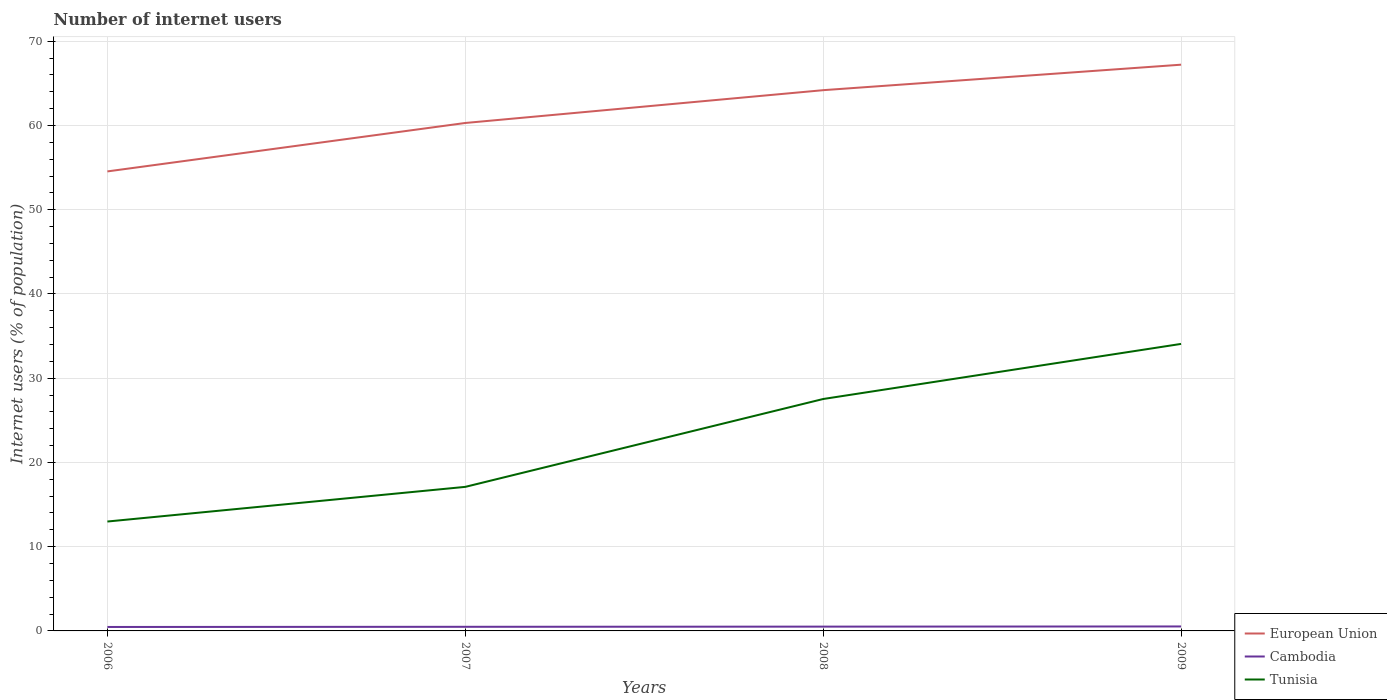How many different coloured lines are there?
Offer a very short reply. 3. Across all years, what is the maximum number of internet users in Cambodia?
Ensure brevity in your answer.  0.47. In which year was the number of internet users in Tunisia maximum?
Offer a terse response. 2006. What is the total number of internet users in Cambodia in the graph?
Provide a short and direct response. -0.02. What is the difference between the highest and the second highest number of internet users in Cambodia?
Provide a short and direct response. 0.06. What is the difference between the highest and the lowest number of internet users in Cambodia?
Offer a very short reply. 2. Is the number of internet users in Cambodia strictly greater than the number of internet users in European Union over the years?
Keep it short and to the point. Yes. How many lines are there?
Keep it short and to the point. 3. Are the values on the major ticks of Y-axis written in scientific E-notation?
Give a very brief answer. No. Does the graph contain grids?
Give a very brief answer. Yes. How are the legend labels stacked?
Your response must be concise. Vertical. What is the title of the graph?
Make the answer very short. Number of internet users. Does "Slovak Republic" appear as one of the legend labels in the graph?
Your response must be concise. No. What is the label or title of the X-axis?
Offer a terse response. Years. What is the label or title of the Y-axis?
Your answer should be very brief. Internet users (% of population). What is the Internet users (% of population) of European Union in 2006?
Keep it short and to the point. 54.55. What is the Internet users (% of population) of Cambodia in 2006?
Provide a succinct answer. 0.47. What is the Internet users (% of population) of Tunisia in 2006?
Your answer should be compact. 12.99. What is the Internet users (% of population) of European Union in 2007?
Offer a very short reply. 60.3. What is the Internet users (% of population) in Cambodia in 2007?
Make the answer very short. 0.49. What is the Internet users (% of population) of European Union in 2008?
Your answer should be very brief. 64.19. What is the Internet users (% of population) in Cambodia in 2008?
Offer a terse response. 0.51. What is the Internet users (% of population) in Tunisia in 2008?
Your response must be concise. 27.53. What is the Internet users (% of population) in European Union in 2009?
Your answer should be compact. 67.21. What is the Internet users (% of population) of Cambodia in 2009?
Provide a succinct answer. 0.53. What is the Internet users (% of population) of Tunisia in 2009?
Your answer should be very brief. 34.07. Across all years, what is the maximum Internet users (% of population) in European Union?
Your response must be concise. 67.21. Across all years, what is the maximum Internet users (% of population) in Cambodia?
Your response must be concise. 0.53. Across all years, what is the maximum Internet users (% of population) of Tunisia?
Provide a short and direct response. 34.07. Across all years, what is the minimum Internet users (% of population) in European Union?
Your response must be concise. 54.55. Across all years, what is the minimum Internet users (% of population) in Cambodia?
Your answer should be very brief. 0.47. Across all years, what is the minimum Internet users (% of population) in Tunisia?
Keep it short and to the point. 12.99. What is the total Internet users (% of population) of European Union in the graph?
Offer a terse response. 246.25. What is the total Internet users (% of population) in Cambodia in the graph?
Provide a short and direct response. 2. What is the total Internet users (% of population) in Tunisia in the graph?
Keep it short and to the point. 91.69. What is the difference between the Internet users (% of population) in European Union in 2006 and that in 2007?
Make the answer very short. -5.75. What is the difference between the Internet users (% of population) of Cambodia in 2006 and that in 2007?
Make the answer very short. -0.02. What is the difference between the Internet users (% of population) of Tunisia in 2006 and that in 2007?
Your answer should be very brief. -4.11. What is the difference between the Internet users (% of population) of European Union in 2006 and that in 2008?
Make the answer very short. -9.64. What is the difference between the Internet users (% of population) of Cambodia in 2006 and that in 2008?
Your answer should be very brief. -0.04. What is the difference between the Internet users (% of population) of Tunisia in 2006 and that in 2008?
Provide a succinct answer. -14.54. What is the difference between the Internet users (% of population) of European Union in 2006 and that in 2009?
Your answer should be very brief. -12.67. What is the difference between the Internet users (% of population) in Cambodia in 2006 and that in 2009?
Your answer should be very brief. -0.06. What is the difference between the Internet users (% of population) of Tunisia in 2006 and that in 2009?
Provide a succinct answer. -21.08. What is the difference between the Internet users (% of population) in European Union in 2007 and that in 2008?
Provide a succinct answer. -3.89. What is the difference between the Internet users (% of population) in Cambodia in 2007 and that in 2008?
Keep it short and to the point. -0.02. What is the difference between the Internet users (% of population) of Tunisia in 2007 and that in 2008?
Offer a very short reply. -10.43. What is the difference between the Internet users (% of population) in European Union in 2007 and that in 2009?
Provide a succinct answer. -6.92. What is the difference between the Internet users (% of population) in Cambodia in 2007 and that in 2009?
Offer a very short reply. -0.04. What is the difference between the Internet users (% of population) in Tunisia in 2007 and that in 2009?
Give a very brief answer. -16.97. What is the difference between the Internet users (% of population) in European Union in 2008 and that in 2009?
Ensure brevity in your answer.  -3.03. What is the difference between the Internet users (% of population) of Cambodia in 2008 and that in 2009?
Provide a succinct answer. -0.02. What is the difference between the Internet users (% of population) in Tunisia in 2008 and that in 2009?
Offer a terse response. -6.54. What is the difference between the Internet users (% of population) in European Union in 2006 and the Internet users (% of population) in Cambodia in 2007?
Give a very brief answer. 54.06. What is the difference between the Internet users (% of population) in European Union in 2006 and the Internet users (% of population) in Tunisia in 2007?
Your answer should be compact. 37.45. What is the difference between the Internet users (% of population) in Cambodia in 2006 and the Internet users (% of population) in Tunisia in 2007?
Your response must be concise. -16.63. What is the difference between the Internet users (% of population) in European Union in 2006 and the Internet users (% of population) in Cambodia in 2008?
Give a very brief answer. 54.04. What is the difference between the Internet users (% of population) in European Union in 2006 and the Internet users (% of population) in Tunisia in 2008?
Provide a short and direct response. 27.02. What is the difference between the Internet users (% of population) in Cambodia in 2006 and the Internet users (% of population) in Tunisia in 2008?
Give a very brief answer. -27.06. What is the difference between the Internet users (% of population) in European Union in 2006 and the Internet users (% of population) in Cambodia in 2009?
Give a very brief answer. 54.02. What is the difference between the Internet users (% of population) in European Union in 2006 and the Internet users (% of population) in Tunisia in 2009?
Give a very brief answer. 20.48. What is the difference between the Internet users (% of population) of Cambodia in 2006 and the Internet users (% of population) of Tunisia in 2009?
Your response must be concise. -33.6. What is the difference between the Internet users (% of population) of European Union in 2007 and the Internet users (% of population) of Cambodia in 2008?
Your response must be concise. 59.79. What is the difference between the Internet users (% of population) of European Union in 2007 and the Internet users (% of population) of Tunisia in 2008?
Ensure brevity in your answer.  32.77. What is the difference between the Internet users (% of population) of Cambodia in 2007 and the Internet users (% of population) of Tunisia in 2008?
Provide a succinct answer. -27.04. What is the difference between the Internet users (% of population) of European Union in 2007 and the Internet users (% of population) of Cambodia in 2009?
Provide a short and direct response. 59.77. What is the difference between the Internet users (% of population) of European Union in 2007 and the Internet users (% of population) of Tunisia in 2009?
Keep it short and to the point. 26.23. What is the difference between the Internet users (% of population) of Cambodia in 2007 and the Internet users (% of population) of Tunisia in 2009?
Your response must be concise. -33.58. What is the difference between the Internet users (% of population) of European Union in 2008 and the Internet users (% of population) of Cambodia in 2009?
Keep it short and to the point. 63.66. What is the difference between the Internet users (% of population) of European Union in 2008 and the Internet users (% of population) of Tunisia in 2009?
Give a very brief answer. 30.12. What is the difference between the Internet users (% of population) of Cambodia in 2008 and the Internet users (% of population) of Tunisia in 2009?
Your response must be concise. -33.56. What is the average Internet users (% of population) of European Union per year?
Provide a succinct answer. 61.56. What is the average Internet users (% of population) in Cambodia per year?
Make the answer very short. 0.5. What is the average Internet users (% of population) of Tunisia per year?
Your answer should be very brief. 22.92. In the year 2006, what is the difference between the Internet users (% of population) of European Union and Internet users (% of population) of Cambodia?
Provide a short and direct response. 54.08. In the year 2006, what is the difference between the Internet users (% of population) of European Union and Internet users (% of population) of Tunisia?
Provide a short and direct response. 41.56. In the year 2006, what is the difference between the Internet users (% of population) in Cambodia and Internet users (% of population) in Tunisia?
Provide a succinct answer. -12.52. In the year 2007, what is the difference between the Internet users (% of population) in European Union and Internet users (% of population) in Cambodia?
Your answer should be compact. 59.81. In the year 2007, what is the difference between the Internet users (% of population) of European Union and Internet users (% of population) of Tunisia?
Offer a very short reply. 43.2. In the year 2007, what is the difference between the Internet users (% of population) in Cambodia and Internet users (% of population) in Tunisia?
Make the answer very short. -16.61. In the year 2008, what is the difference between the Internet users (% of population) of European Union and Internet users (% of population) of Cambodia?
Give a very brief answer. 63.68. In the year 2008, what is the difference between the Internet users (% of population) in European Union and Internet users (% of population) in Tunisia?
Your answer should be very brief. 36.66. In the year 2008, what is the difference between the Internet users (% of population) of Cambodia and Internet users (% of population) of Tunisia?
Keep it short and to the point. -27.02. In the year 2009, what is the difference between the Internet users (% of population) of European Union and Internet users (% of population) of Cambodia?
Provide a short and direct response. 66.68. In the year 2009, what is the difference between the Internet users (% of population) of European Union and Internet users (% of population) of Tunisia?
Give a very brief answer. 33.14. In the year 2009, what is the difference between the Internet users (% of population) of Cambodia and Internet users (% of population) of Tunisia?
Offer a terse response. -33.54. What is the ratio of the Internet users (% of population) of European Union in 2006 to that in 2007?
Your response must be concise. 0.9. What is the ratio of the Internet users (% of population) in Cambodia in 2006 to that in 2007?
Offer a very short reply. 0.96. What is the ratio of the Internet users (% of population) of Tunisia in 2006 to that in 2007?
Keep it short and to the point. 0.76. What is the ratio of the Internet users (% of population) of European Union in 2006 to that in 2008?
Your response must be concise. 0.85. What is the ratio of the Internet users (% of population) of Cambodia in 2006 to that in 2008?
Provide a short and direct response. 0.92. What is the ratio of the Internet users (% of population) in Tunisia in 2006 to that in 2008?
Your answer should be very brief. 0.47. What is the ratio of the Internet users (% of population) in European Union in 2006 to that in 2009?
Offer a very short reply. 0.81. What is the ratio of the Internet users (% of population) in Cambodia in 2006 to that in 2009?
Provide a succinct answer. 0.88. What is the ratio of the Internet users (% of population) of Tunisia in 2006 to that in 2009?
Provide a succinct answer. 0.38. What is the ratio of the Internet users (% of population) of European Union in 2007 to that in 2008?
Your response must be concise. 0.94. What is the ratio of the Internet users (% of population) in Cambodia in 2007 to that in 2008?
Your response must be concise. 0.96. What is the ratio of the Internet users (% of population) of Tunisia in 2007 to that in 2008?
Keep it short and to the point. 0.62. What is the ratio of the Internet users (% of population) of European Union in 2007 to that in 2009?
Your answer should be compact. 0.9. What is the ratio of the Internet users (% of population) of Cambodia in 2007 to that in 2009?
Make the answer very short. 0.92. What is the ratio of the Internet users (% of population) in Tunisia in 2007 to that in 2009?
Provide a short and direct response. 0.5. What is the ratio of the Internet users (% of population) of European Union in 2008 to that in 2009?
Offer a very short reply. 0.95. What is the ratio of the Internet users (% of population) of Cambodia in 2008 to that in 2009?
Your response must be concise. 0.96. What is the ratio of the Internet users (% of population) of Tunisia in 2008 to that in 2009?
Provide a succinct answer. 0.81. What is the difference between the highest and the second highest Internet users (% of population) in European Union?
Provide a short and direct response. 3.03. What is the difference between the highest and the second highest Internet users (% of population) of Cambodia?
Offer a terse response. 0.02. What is the difference between the highest and the second highest Internet users (% of population) of Tunisia?
Make the answer very short. 6.54. What is the difference between the highest and the lowest Internet users (% of population) in European Union?
Keep it short and to the point. 12.67. What is the difference between the highest and the lowest Internet users (% of population) of Cambodia?
Your answer should be compact. 0.06. What is the difference between the highest and the lowest Internet users (% of population) of Tunisia?
Ensure brevity in your answer.  21.08. 